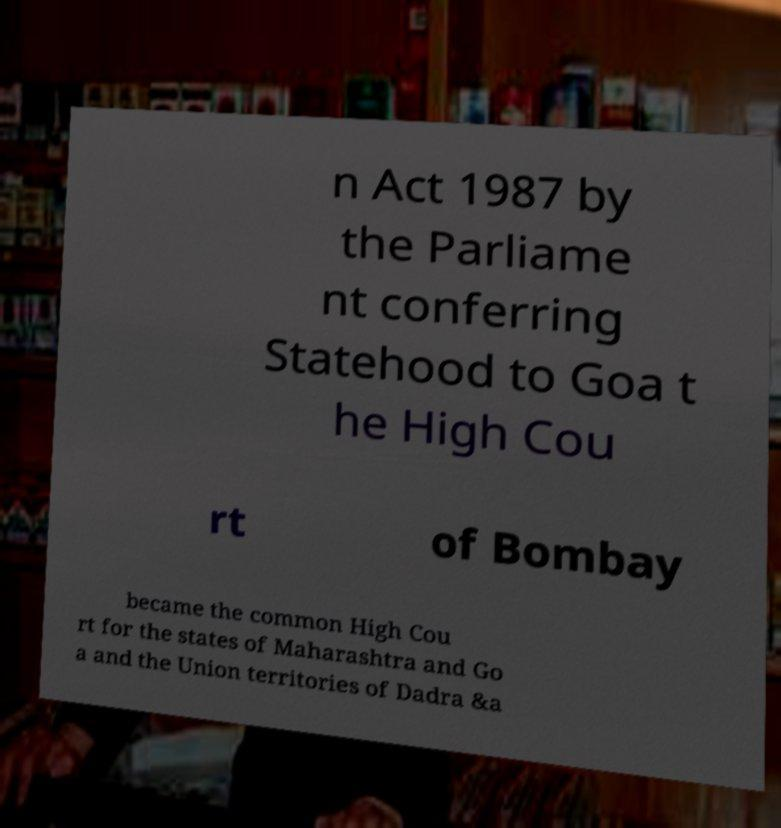For documentation purposes, I need the text within this image transcribed. Could you provide that? n Act 1987 by the Parliame nt conferring Statehood to Goa t he High Cou rt of Bombay became the common High Cou rt for the states of Maharashtra and Go a and the Union territories of Dadra &a 